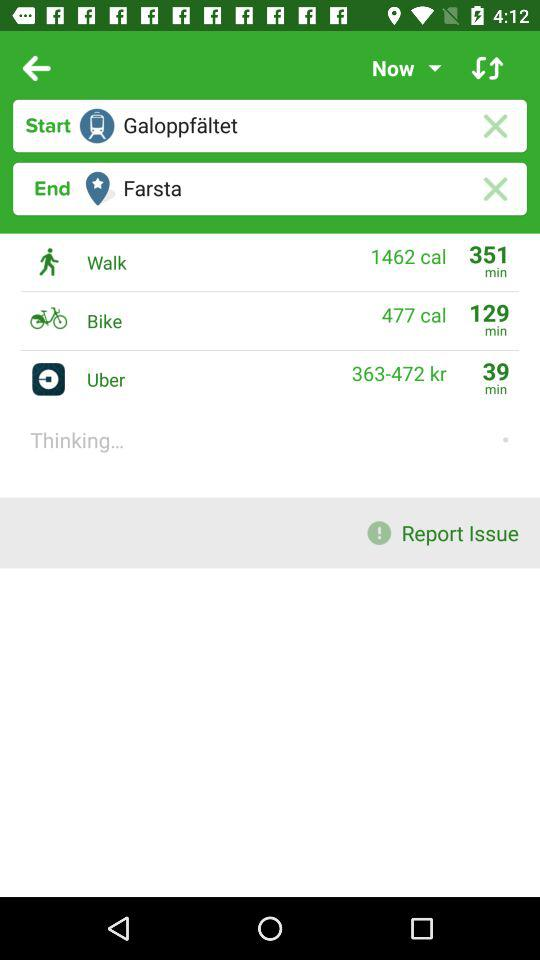How much time will it take to walk? It will take 351 minutes to walk there. 